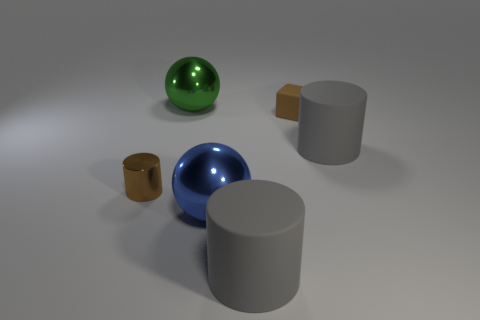Subtract all purple cubes. How many gray cylinders are left? 2 Subtract 1 cylinders. How many cylinders are left? 2 Add 3 large green shiny things. How many objects exist? 9 Subtract all cubes. How many objects are left? 5 Subtract all small green objects. Subtract all brown cylinders. How many objects are left? 5 Add 3 large gray cylinders. How many large gray cylinders are left? 5 Add 2 cubes. How many cubes exist? 3 Subtract 0 purple cylinders. How many objects are left? 6 